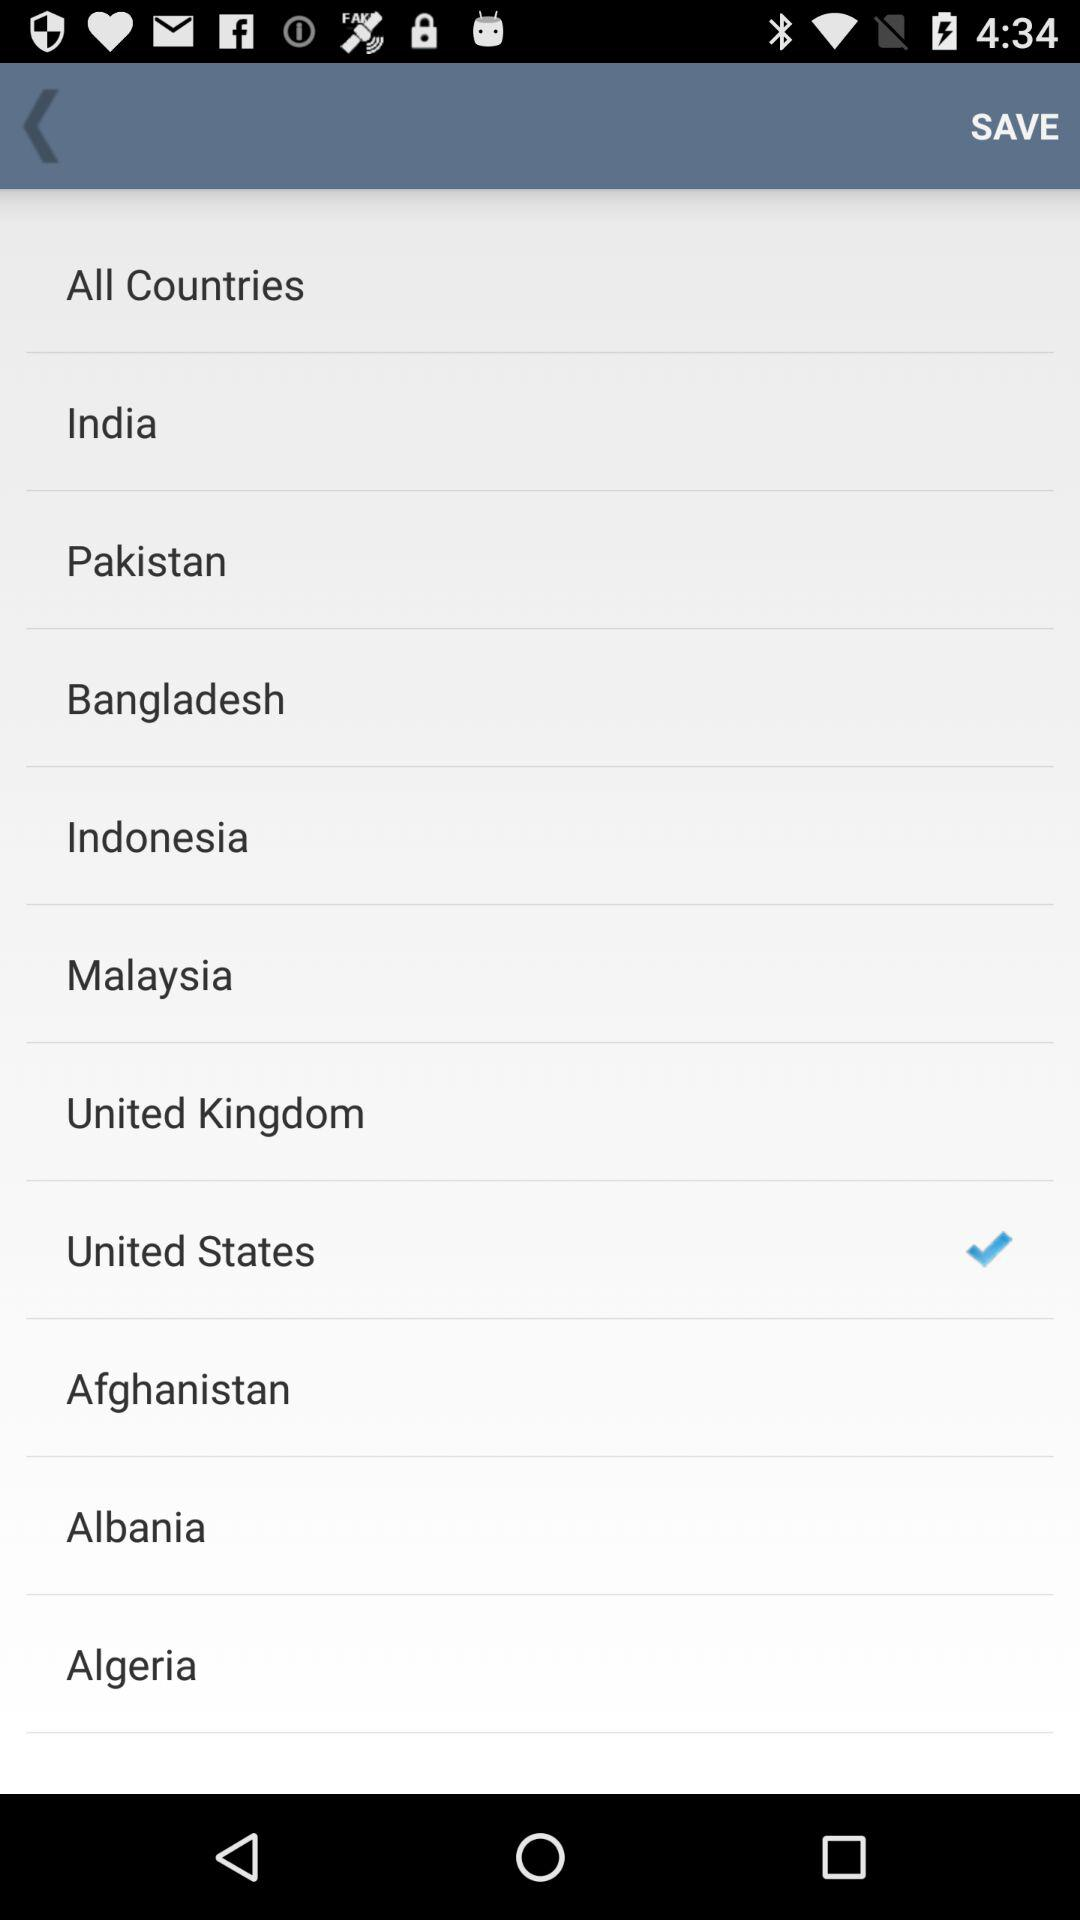What is the selected country? The selected country is the United States. 